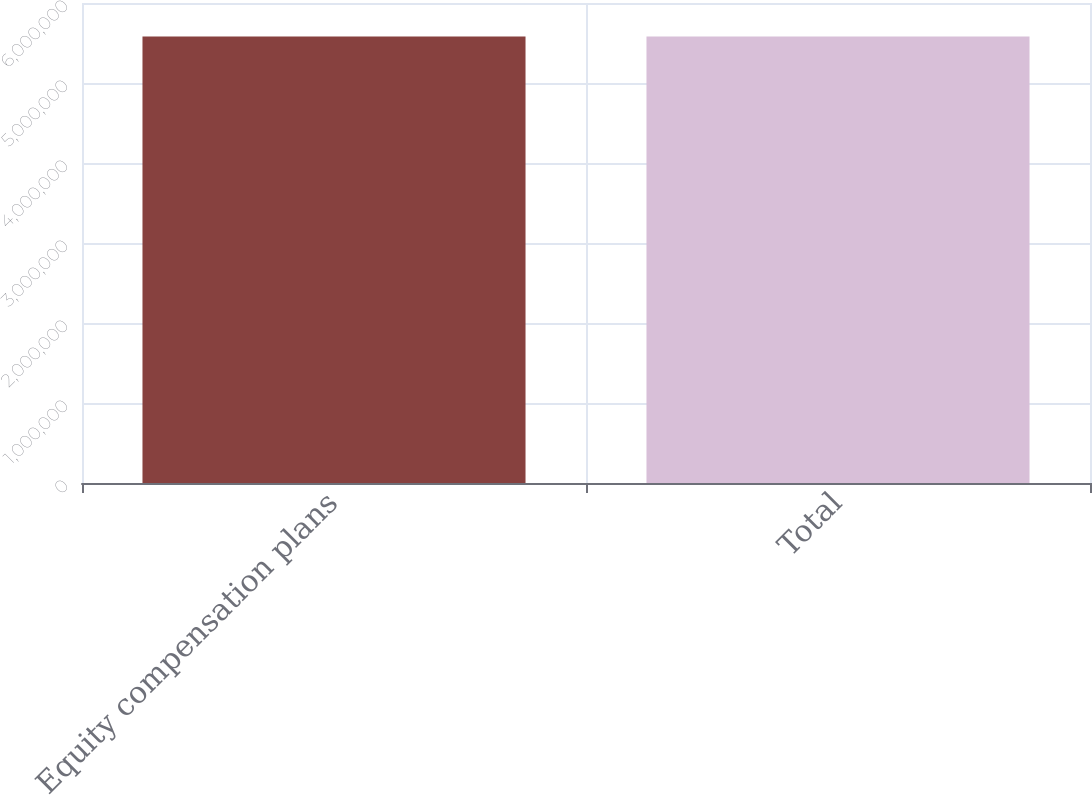<chart> <loc_0><loc_0><loc_500><loc_500><bar_chart><fcel>Equity compensation plans<fcel>Total<nl><fcel>5.5824e+06<fcel>5.5824e+06<nl></chart> 